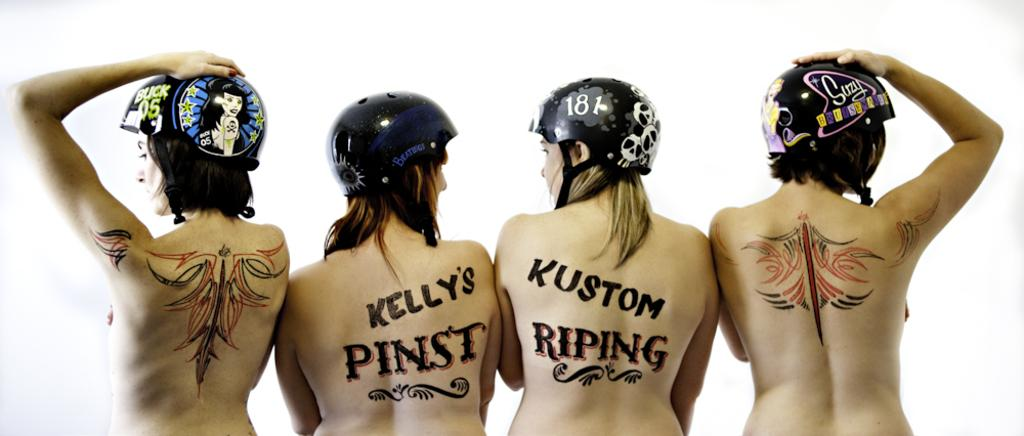How many people are in the image? There are four women in the image. What are the women wearing on their heads? The women are wearing helmets. Are there any designs or text on the helmets? Yes, there is writing and drawings on the women's helmets. What color is the writing and drawings on the helmets? The writing and drawings are in white color. Where can the store selling toothpaste be found in the image? There is no store or toothpaste present in the image; it features four women wearing helmets with writing and drawings. Can you see any ducks in the image? There are no ducks present in the image. 